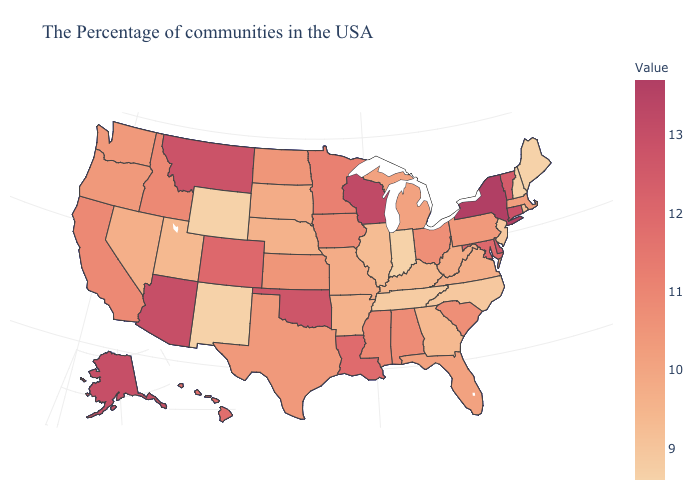Which states have the lowest value in the USA?
Concise answer only. Maine, New Hampshire, Indiana, Wyoming, New Mexico. Which states have the lowest value in the USA?
Be succinct. Maine, New Hampshire, Indiana, Wyoming, New Mexico. Does New York have the highest value in the USA?
Short answer required. Yes. Does Washington have the lowest value in the West?
Short answer required. No. 